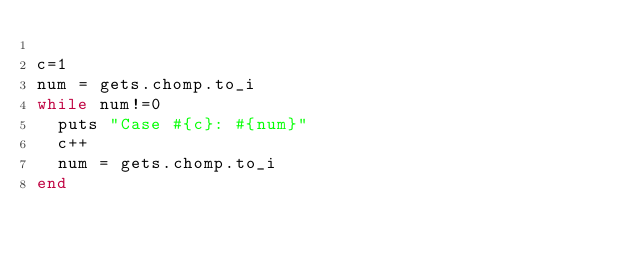Convert code to text. <code><loc_0><loc_0><loc_500><loc_500><_Ruby_>
c=1
num = gets.chomp.to_i
while num!=0 
	puts "Case #{c}: #{num}"
	c++
	num = gets.chomp.to_i
end</code> 